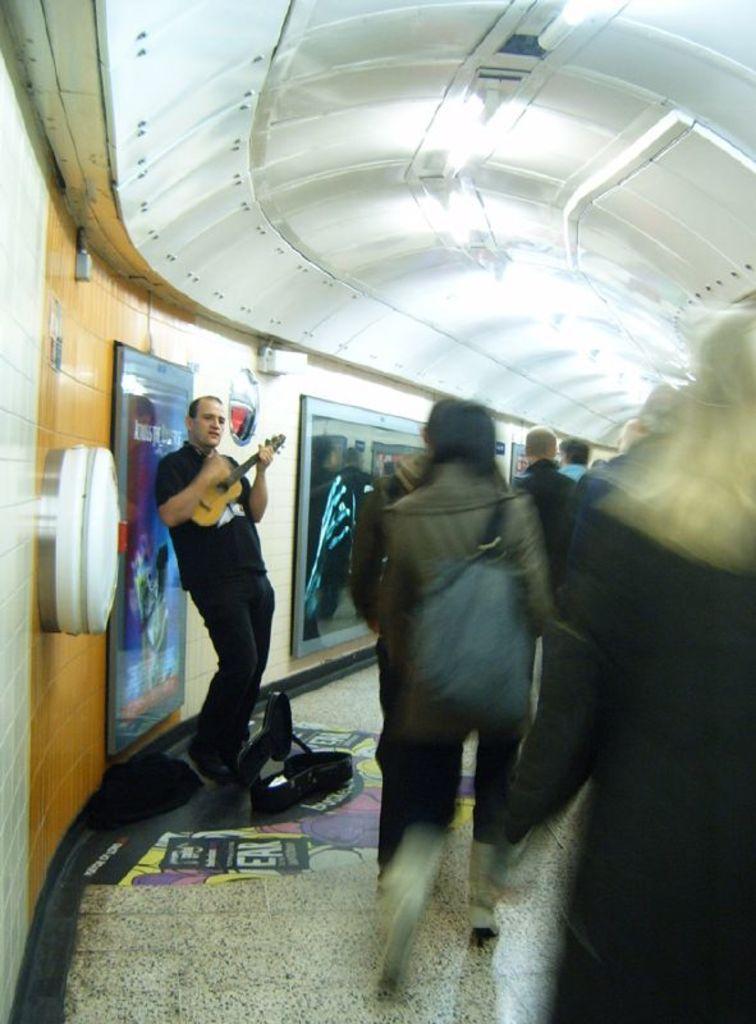Describe this image in one or two sentences. As we can see in the image, there are few people and a banner over here. The man who is standing here is holding guitar 